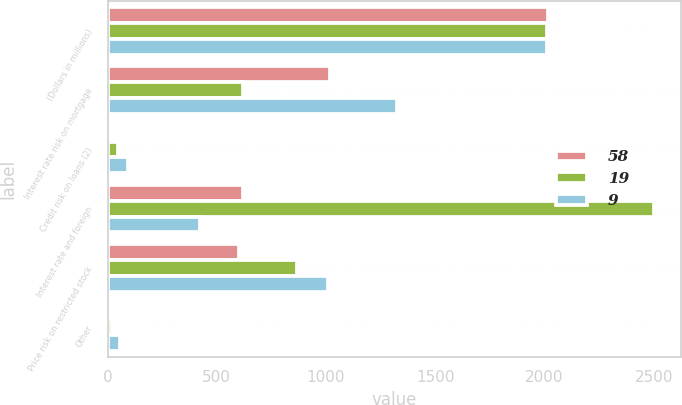<chart> <loc_0><loc_0><loc_500><loc_500><stacked_bar_chart><ecel><fcel>(Dollars in millions)<fcel>Interest rate risk on mortgage<fcel>Credit risk on loans (2)<fcel>Interest rate and foreign<fcel>Price risk on restricted stock<fcel>Other<nl><fcel>58<fcel>2014<fcel>1017<fcel>16<fcel>619<fcel>600<fcel>9<nl><fcel>19<fcel>2013<fcel>619<fcel>47<fcel>2501<fcel>865<fcel>19<nl><fcel>9<fcel>2012<fcel>1324<fcel>95<fcel>424<fcel>1008<fcel>58<nl></chart> 